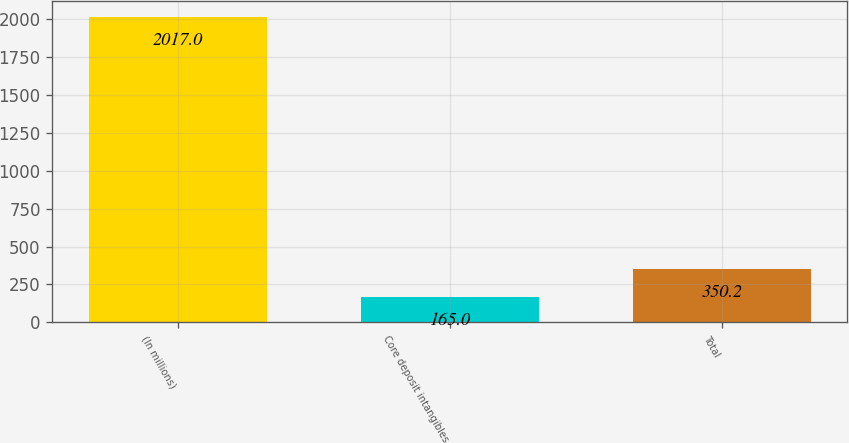Convert chart to OTSL. <chart><loc_0><loc_0><loc_500><loc_500><bar_chart><fcel>(In millions)<fcel>Core deposit intangibles<fcel>Total<nl><fcel>2017<fcel>165<fcel>350.2<nl></chart> 